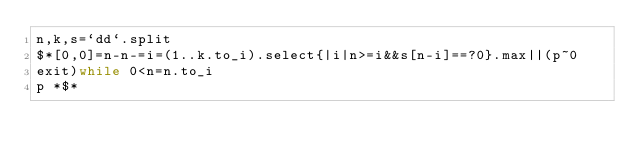<code> <loc_0><loc_0><loc_500><loc_500><_Ruby_>n,k,s=`dd`.split
$*[0,0]=n-n-=i=(1..k.to_i).select{|i|n>=i&&s[n-i]==?0}.max||(p~0
exit)while 0<n=n.to_i
p *$*</code> 